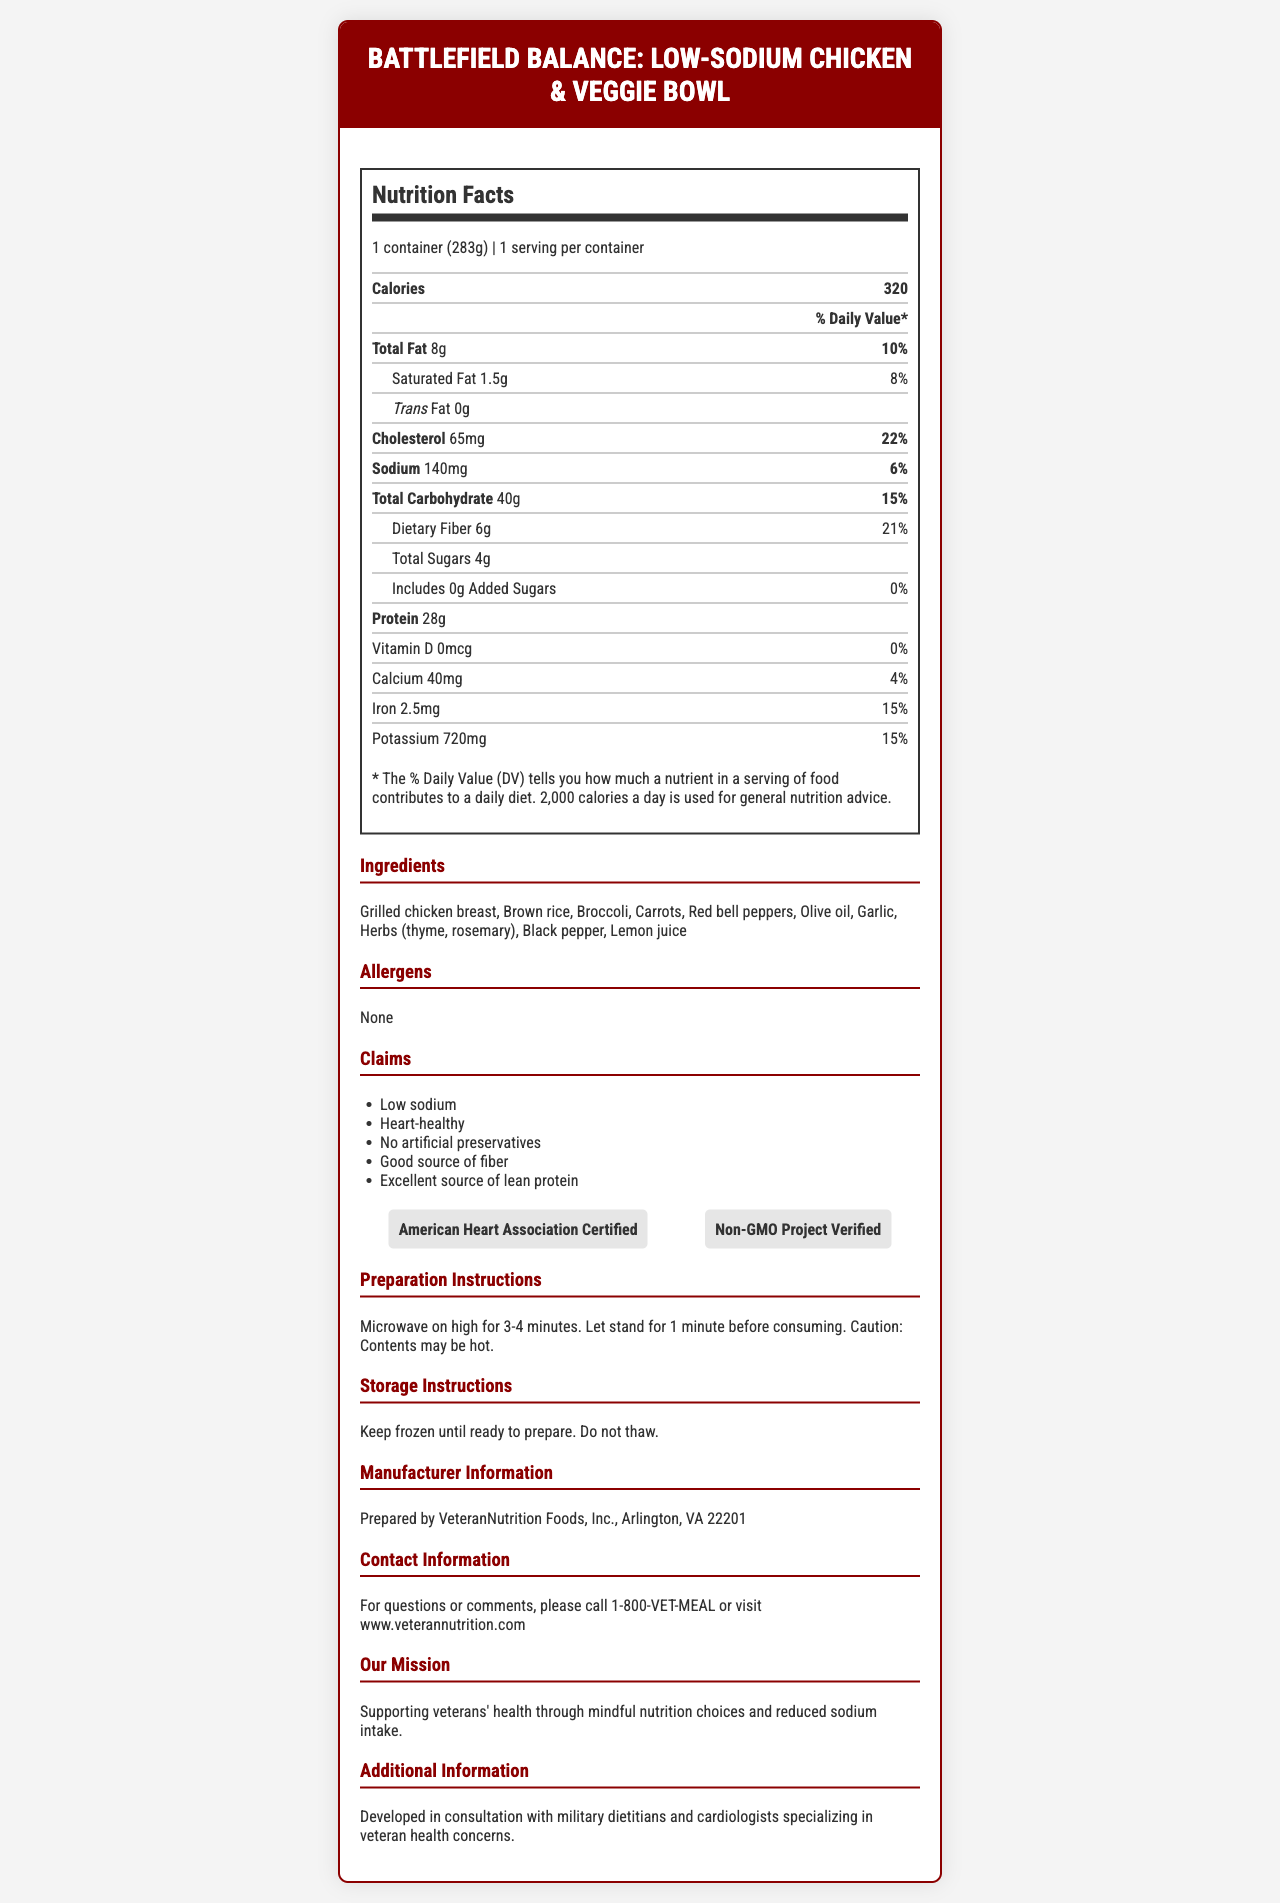what is the serving size for this meal? The serving size is noted at the top of the nutrition facts section as "1 container (283g)".
Answer: 1 container (283g) how many calories are in one serving of the Battlefield Balance: Low-Sodium Chicken & Veggie Bowl? The number of calories per serving is clearly listed under the "Calories" section in the nutrition facts.
Answer: 320 calories what percentage of the daily value of sodium is in one serving? The sodium content is listed as 140mg which is 6% of the daily value.
Answer: 6% List the main ingredients in this product. These ingredients are listed under the ingredients section of the document.
Answer: Grilled chicken breast, Brown rice, Broccoli, Carrots, Red bell peppers, Olive oil, Garlic, Herbs (thyme, rosemary), Black pepper, Lemon juice what are the preparation instructions for this frozen meal? The preparation instructions are given towards the bottom of the document.
Answer: Microwave on high for 3-4 minutes. Let stand for 1 minute before consuming. Caution: Contents may be hot. Which organization certified this product as heart-healthy? The product has an American Heart Association Certified label under the certifications section.
Answer: American Heart Association Which nutrient has the highest percentage of daily value per serving? Cholesterol has the highest daily value percentage listed at 22%.
Answer: Cholesterol at 22% What claims are made about this product? These claims are listed in the claims section of the document.
Answer: Low sodium, Heart-healthy, No artificial preservatives, Good source of fiber, Excellent source of lean protein What is the total fat content in one serving of this meal? The total fat content is listed under the "Total Fat" section in the nutrition facts.
Answer: 8g How much protein is in one serving? The protein content per serving is listed under the "Protein" section of the nutrition facts.
Answer: 28g Does this product contain any allergens? The allergens section lists "None," indicating there are no common allergens in this product.
Answer: No Is added sugar present in this meal? The added sugars section indicates 0g of added sugars, showing none are present.
Answer: No What would be the best summary of the document? This summary encapsulates the main elements covered in the document including nutrition facts, claims, and additional instructions.
Answer: The Battlefield Balance: Low-Sodium Chicken & Veggie Bowl is a low-sodium, heart-healthy frozen meal aimed at veterans, with clear nutritional information, certifications, preparation, and storage instructions. What is a unique selling point of this product mentioned in the document? This unique selling point is listed under the "additional information" section.
Answer: Developed in consultation with military dietitians and cardiologists specializing in veteran health concerns. What is the contact information for this product? This contact information is provided toward the end of the document.
Answer: For questions or comments, please call 1-800-VET-MEAL or visit www.veterannutrition.com Is this meal a good source of dietary fiber? The product contains 6g of dietary fiber which is 21% of the daily value, categorizing it as a good source of fiber.
Answer: Yes What is the potently unaddressed issue in terms of veteran health concerns mentioned in this document? The document focuses on nutritional aspects specific to hypertension but does not provide comprehensive information on all possible veteran health concerns.
Answer: Cannot be determined Which of the following is NOT a listed ingredient? 
1. Spinach
2. Carrots
3. Grilled chicken breast The ingredient list does not mention spinach, but it does include carrots and grilled chicken breast.
Answer: 1. Spinach Who is the manufacturer of this product? 
A. HealthyHeart Meals
B. VeteranNutrition Foods, Inc. 
C. FitVets Nutrition The manufacturer information section lists "Prepared by VeteranNutrition Foods, Inc."
Answer: B. VeteranNutrition Foods, Inc. 